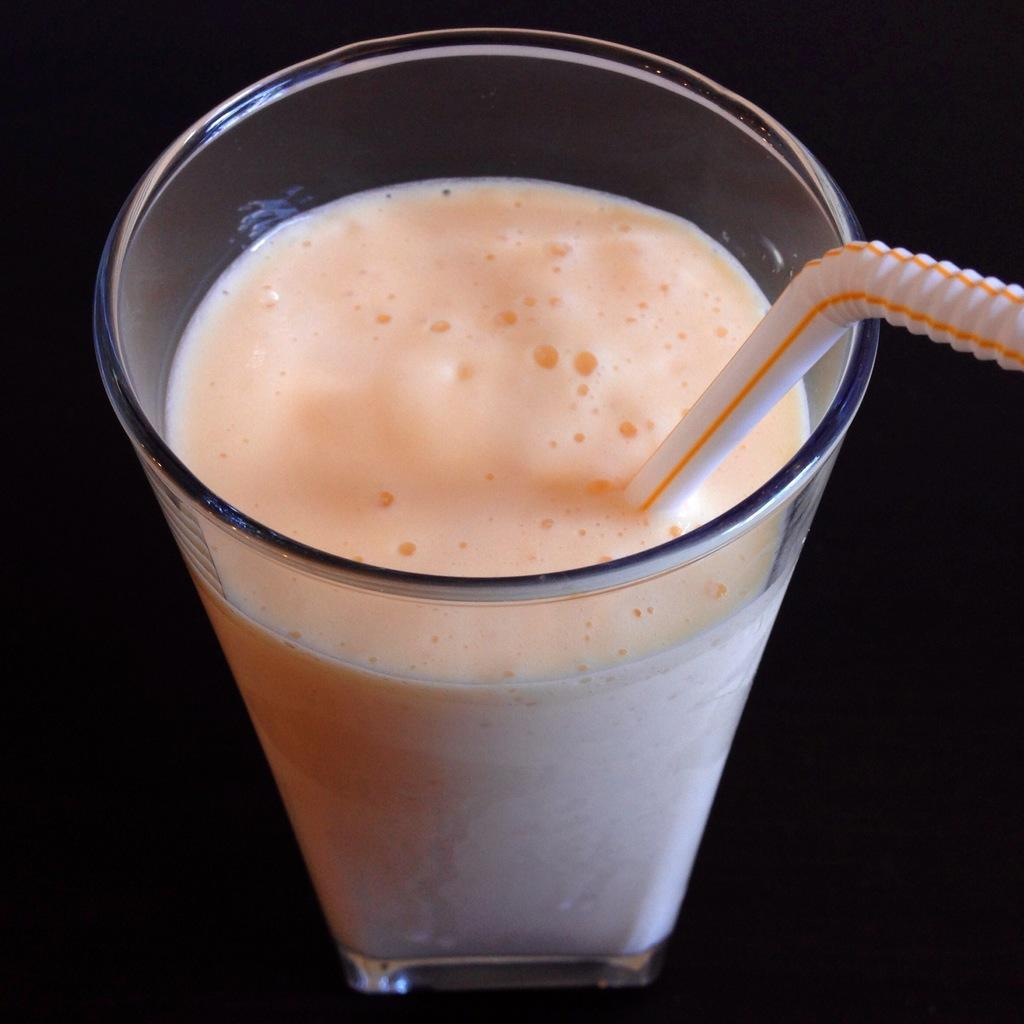What is in the glass that is visible in the image? The glass contains liquid in the image. What object is inside the glass? There is a straw in the glass. What is the color of the surface on which the glass is placed? The glass is placed on a black surface. What type of flooring can be seen under the glass in the image? There is no flooring visible under the glass in the image; it is placed on a black surface. What type of learning is taking place in the image? There is no learning activity depicted in the image; it features a glass with liquid and a straw. 